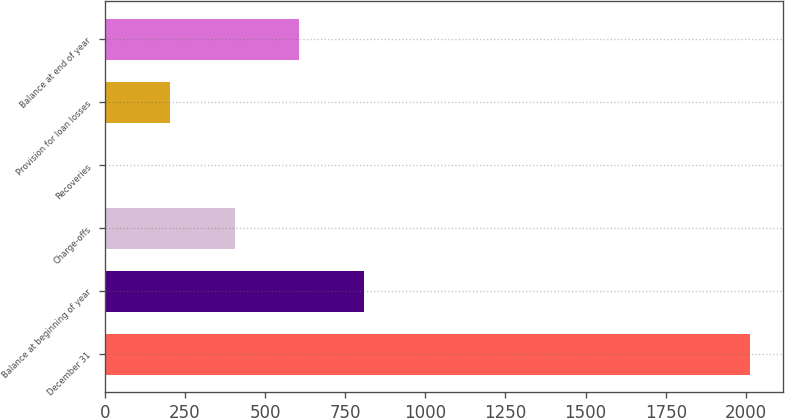<chart> <loc_0><loc_0><loc_500><loc_500><bar_chart><fcel>December 31<fcel>Balance at beginning of year<fcel>Charge-offs<fcel>Recoveries<fcel>Provision for loan losses<fcel>Balance at end of year<nl><fcel>2014<fcel>807.4<fcel>405.2<fcel>3<fcel>204.1<fcel>606.3<nl></chart> 